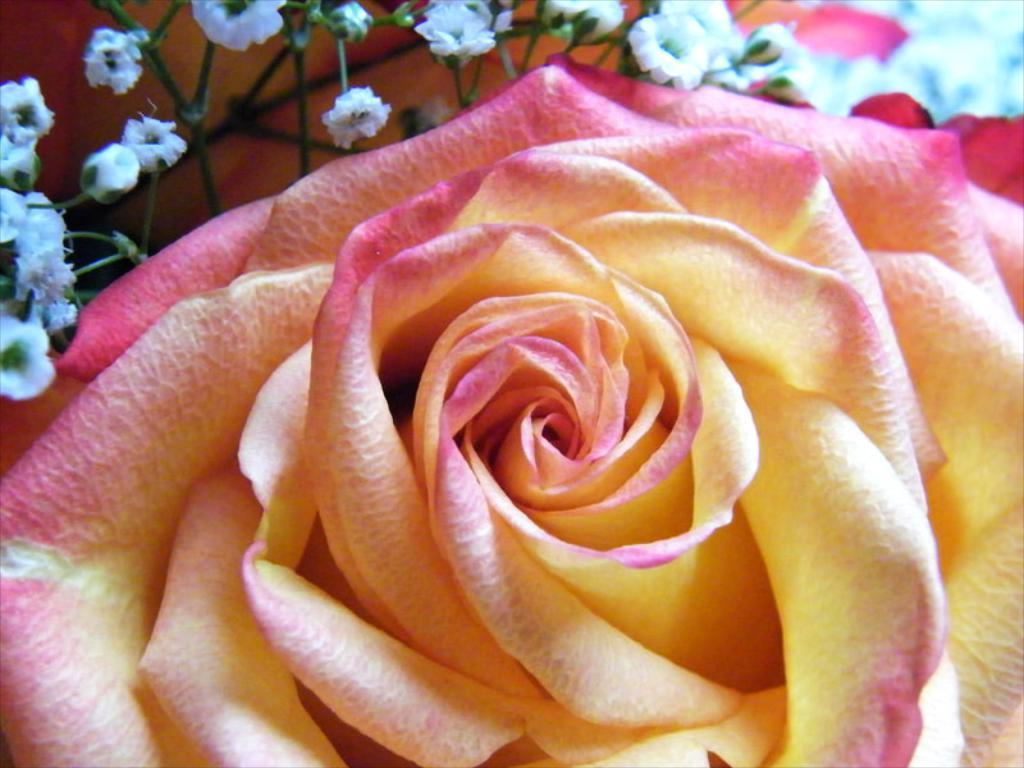What is the main subject in the front of the image? There is a flower in the front of the image. Can you describe the flower at the top of the image? There is a white color flower at the top of the image. Is the actor smiling in the image? There is no actor or any indication of a smile in the image; it features a flower. 